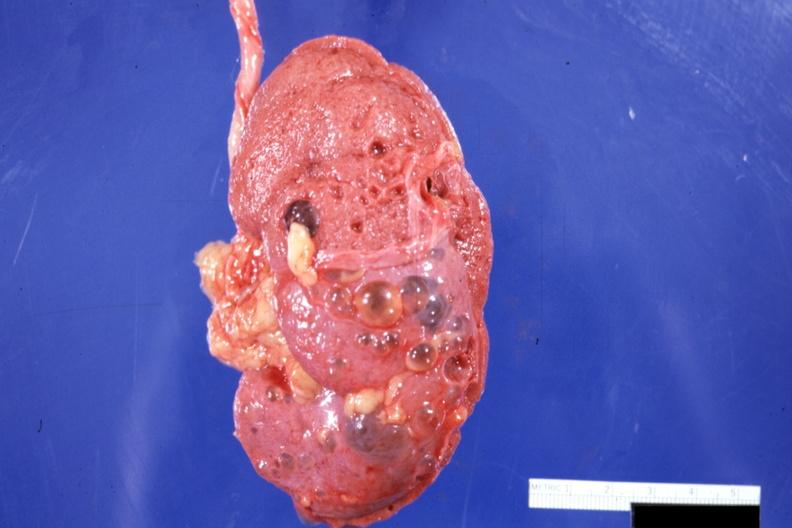s fibrotic lesion present?
Answer the question using a single word or phrase. No 